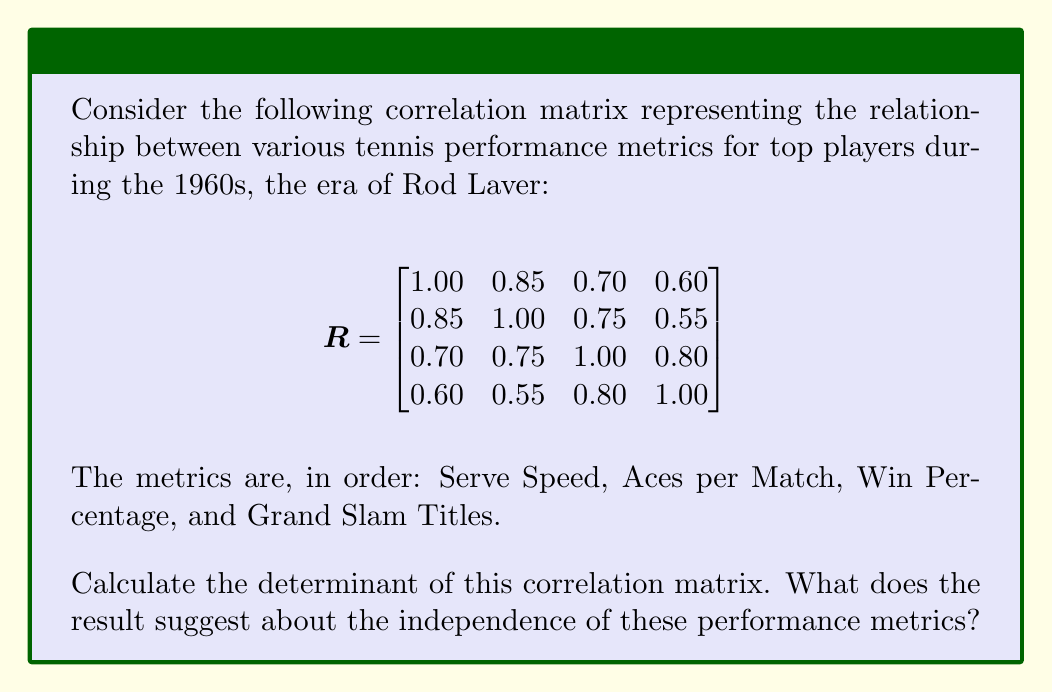Provide a solution to this math problem. To solve this problem, we need to calculate the determinant of the 4x4 correlation matrix. Let's approach this step-by-step:

1) For a 4x4 matrix $A = [a_{ij}]$, the determinant can be calculated using the following formula:

   $det(A) = a_{11}M_{11} - a_{12}M_{12} + a_{13}M_{13} - a_{14}M_{14}$

   where $M_{ij}$ is the minor of element $a_{ij}$.

2) Let's calculate each minor:

   $M_{11} = \begin{vmatrix}
   1.00 & 0.75 & 0.55 \\
   0.75 & 1.00 & 0.80 \\
   0.55 & 0.80 & 1.00
   \end{vmatrix} = 1.00 - 0.75^2 - 0.55^2 - 0.80^2 + 2(0.75)(0.55)(0.80) = 0.04625$

   $M_{12} = -\begin{vmatrix}
   0.85 & 0.75 & 0.55 \\
   0.70 & 1.00 & 0.80 \\
   0.60 & 0.80 & 1.00
   \end{vmatrix} = -(0.85 - 0.75(0.70) - 0.55(0.60) - 0.80(0.85) + 2(0.75)(0.55)(0.70)) = -0.03875$

   $M_{13} = \begin{vmatrix}
   0.85 & 1.00 & 0.55 \\
   0.70 & 0.75 & 0.80 \\
   0.60 & 0.55 & 1.00
   \end{vmatrix} = 0.85 - 0.70 - 0.55(0.60) - 0.80(0.85) + 2(1.00)(0.55)(0.70) = 0.03375$

   $M_{14} = -\begin{vmatrix}
   0.85 & 1.00 & 0.75 \\
   0.70 & 0.75 & 1.00 \\
   0.60 & 0.55 & 0.80
   \end{vmatrix} = -(0.85(0.75(0.80) - 0.55) - 1.00(0.70(0.80) - 0.60(0.75)) + 0.75(0.70(0.55) - 0.60)) = -0.02875$

3) Now, let's apply these to our determinant formula:

   $det(A) = 1.00(0.04625) - 0.85(-0.03875) + 0.70(0.03375) - 0.60(-0.02875)$
   
   $= 0.04625 + 0.0329375 + 0.0236250 + 0.0172500$
   
   $= 0.1200625$

4) Interpretation: The determinant is close to zero, but not exactly zero. This suggests that the performance metrics are highly correlated but not perfectly linearly dependent. In the context of tennis rankings, this implies that these metrics (Serve Speed, Aces per Match, Win Percentage, and Grand Slam Titles) are strongly related to each other, as one might expect, but each still provides some unique information about a player's performance.
Answer: 0.1200625; suggests high correlation but not perfect linear dependence between metrics. 